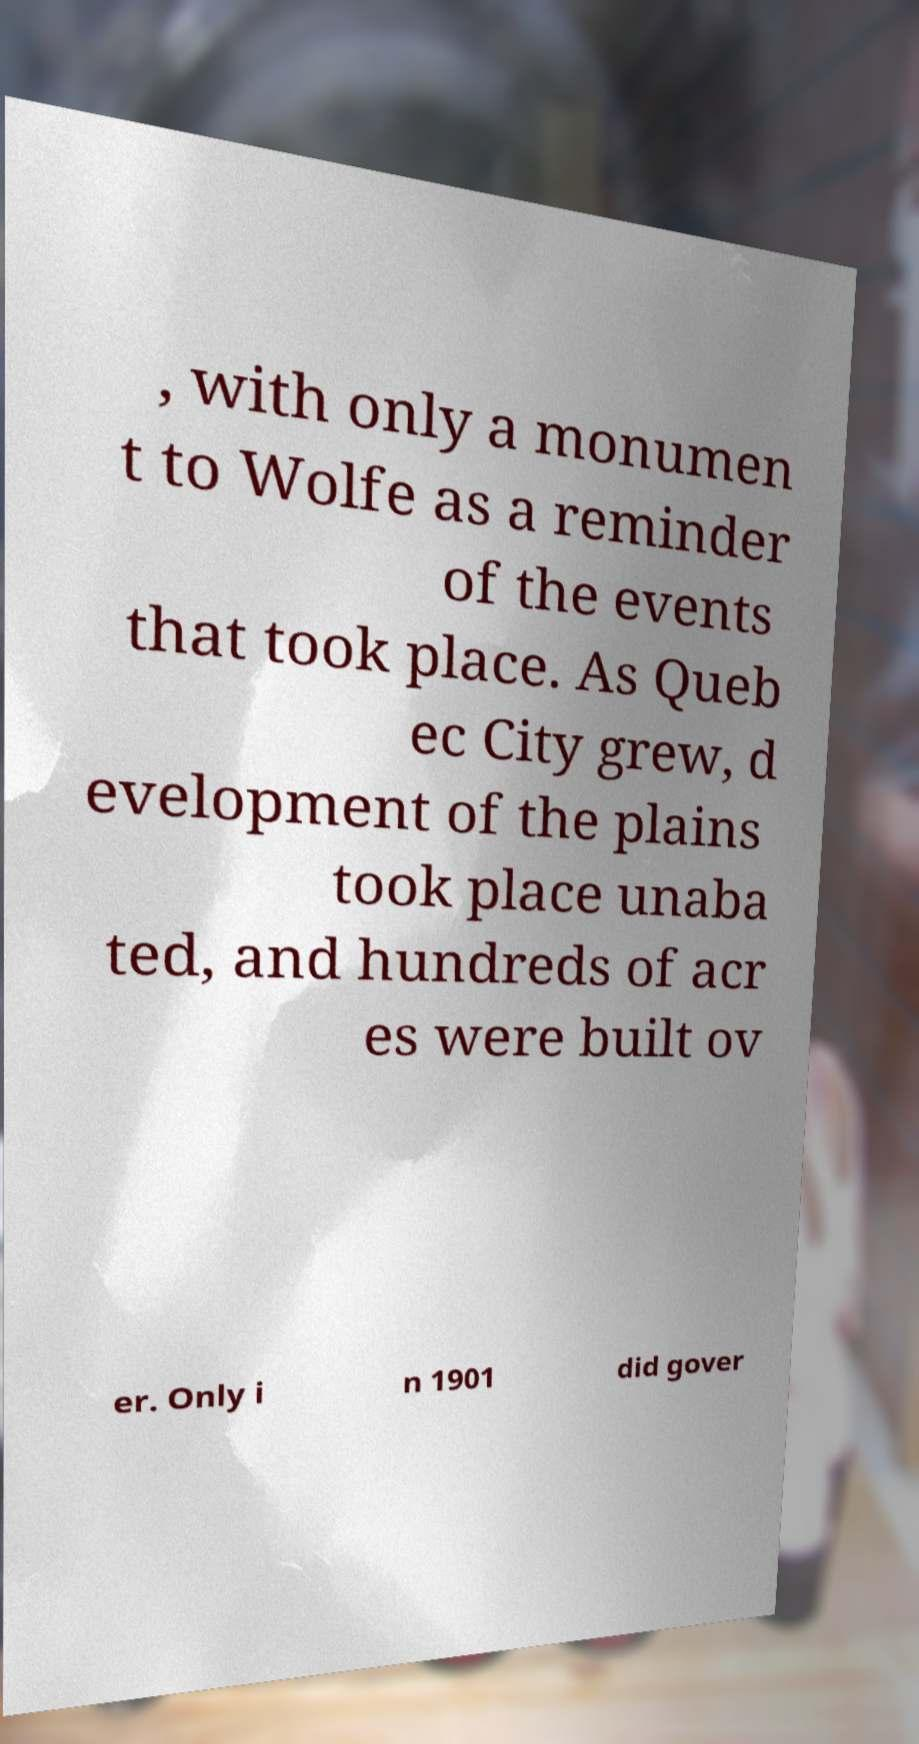Please identify and transcribe the text found in this image. , with only a monumen t to Wolfe as a reminder of the events that took place. As Queb ec City grew, d evelopment of the plains took place unaba ted, and hundreds of acr es were built ov er. Only i n 1901 did gover 